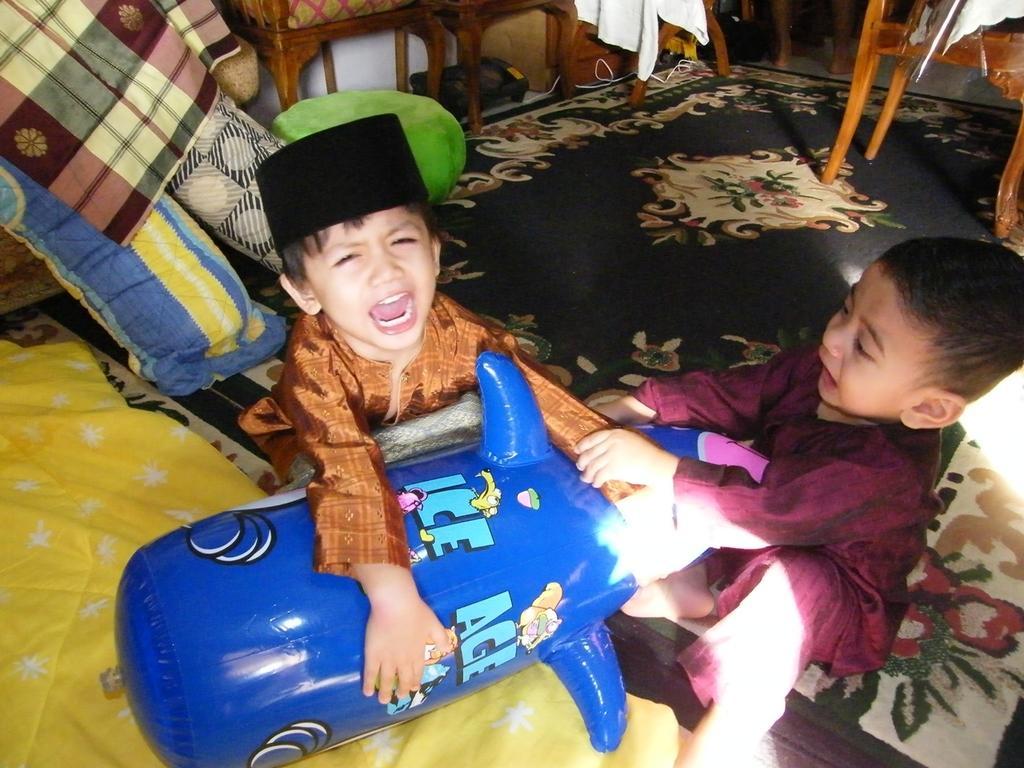Can you describe this image briefly? In this picture we can see two children shouting for the toy and in the background we can see one more toy, chair,machine, cloth, mattress. 